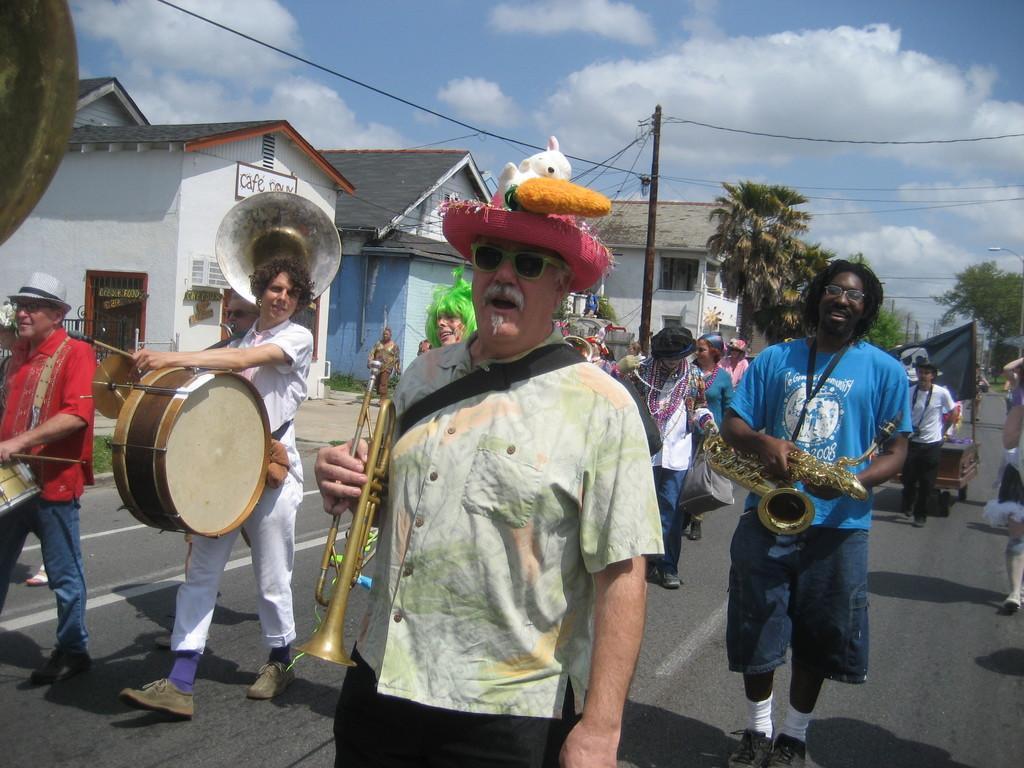In one or two sentences, can you explain what this image depicts? In the image we can see group of persons were walking on the road and holding musical instruments. On the right two persons were holding trumpet. On the left two persons were holding drum and they were smiling. In the back ground we can see sky with clouds,buildings with black roof,trees,door and banner. 